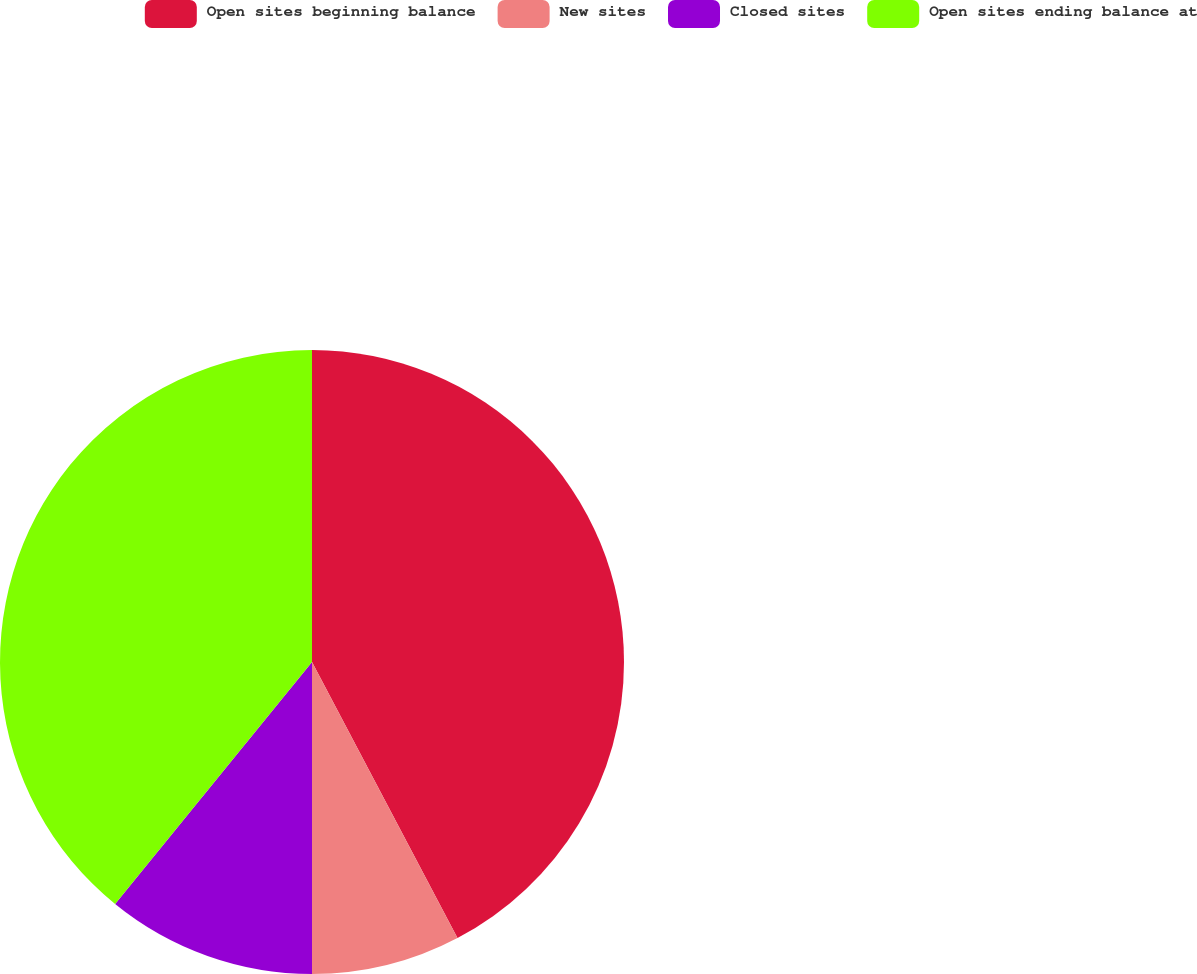Convert chart to OTSL. <chart><loc_0><loc_0><loc_500><loc_500><pie_chart><fcel>Open sites beginning balance<fcel>New sites<fcel>Closed sites<fcel>Open sites ending balance at<nl><fcel>42.28%<fcel>7.72%<fcel>10.87%<fcel>39.13%<nl></chart> 